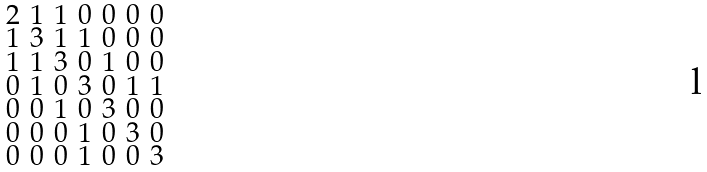<formula> <loc_0><loc_0><loc_500><loc_500>\begin{smallmatrix} 2 & 1 & 1 & 0 & 0 & 0 & 0 \\ 1 & 3 & 1 & 1 & 0 & 0 & 0 \\ 1 & 1 & 3 & 0 & 1 & 0 & 0 \\ 0 & 1 & 0 & 3 & 0 & 1 & 1 \\ 0 & 0 & 1 & 0 & 3 & 0 & 0 \\ 0 & 0 & 0 & 1 & 0 & 3 & 0 \\ 0 & 0 & 0 & 1 & 0 & 0 & 3 \end{smallmatrix}</formula> 